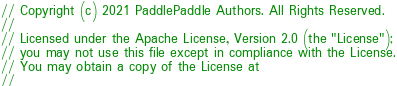<code> <loc_0><loc_0><loc_500><loc_500><_Cuda_>// Copyright (c) 2021 PaddlePaddle Authors. All Rights Reserved.
//
// Licensed under the Apache License, Version 2.0 (the "License");
// you may not use this file except in compliance with the License.
// You may obtain a copy of the License at
//</code> 